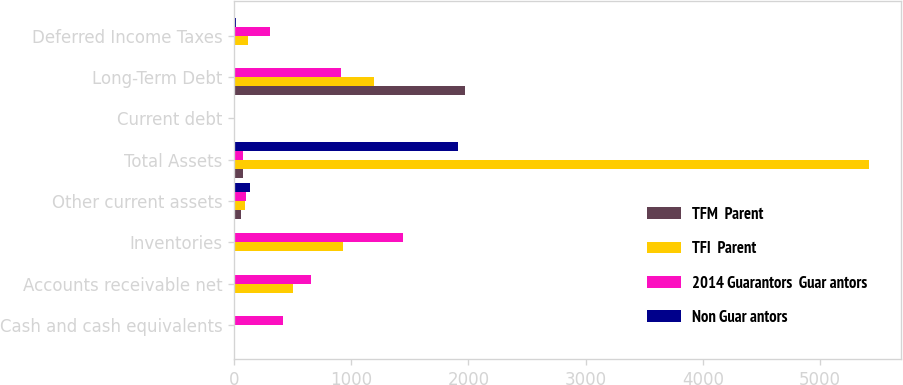Convert chart. <chart><loc_0><loc_0><loc_500><loc_500><stacked_bar_chart><ecel><fcel>Cash and cash equivalents<fcel>Accounts receivable net<fcel>Inventories<fcel>Other current assets<fcel>Total Assets<fcel>Current debt<fcel>Long-Term Debt<fcel>Deferred Income Taxes<nl><fcel>TFM  Parent<fcel>1<fcel>1<fcel>2<fcel>62<fcel>78.5<fcel>2<fcel>1972<fcel>0<nl><fcel>TFI  Parent<fcel>1<fcel>506<fcel>926<fcel>95<fcel>5418<fcel>0<fcel>1198<fcel>120<nl><fcel>2014 Guarantors  Guar antors<fcel>414<fcel>656<fcel>1440<fcel>102<fcel>78.5<fcel>0<fcel>916<fcel>310<nl><fcel>Non Guar antors<fcel>0<fcel>0<fcel>0<fcel>133<fcel>1908<fcel>0<fcel>0<fcel>15<nl></chart> 